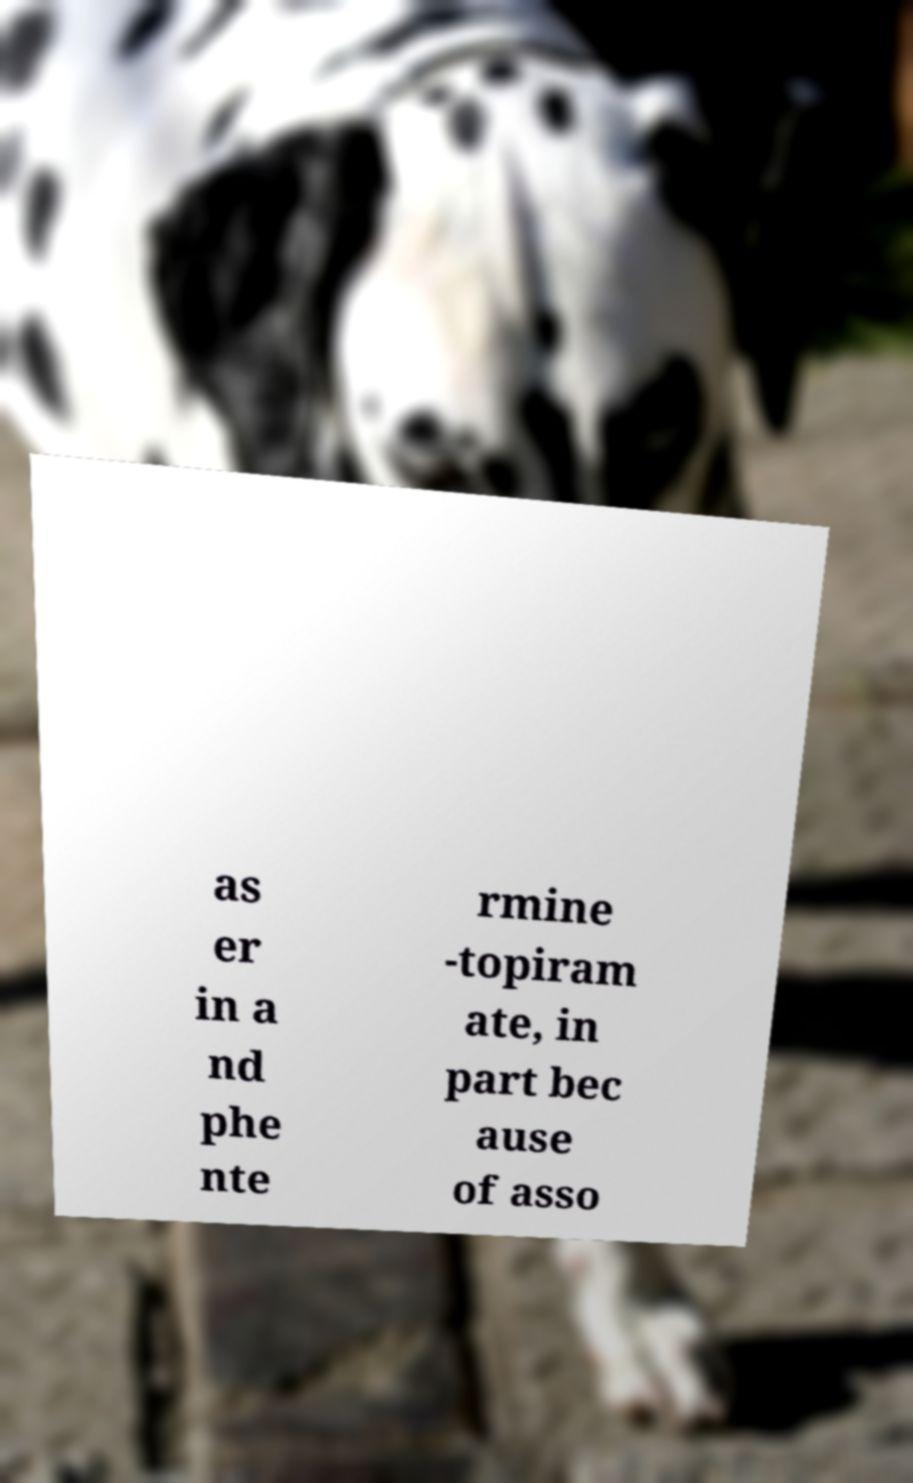Please read and relay the text visible in this image. What does it say? as er in a nd phe nte rmine -topiram ate, in part bec ause of asso 